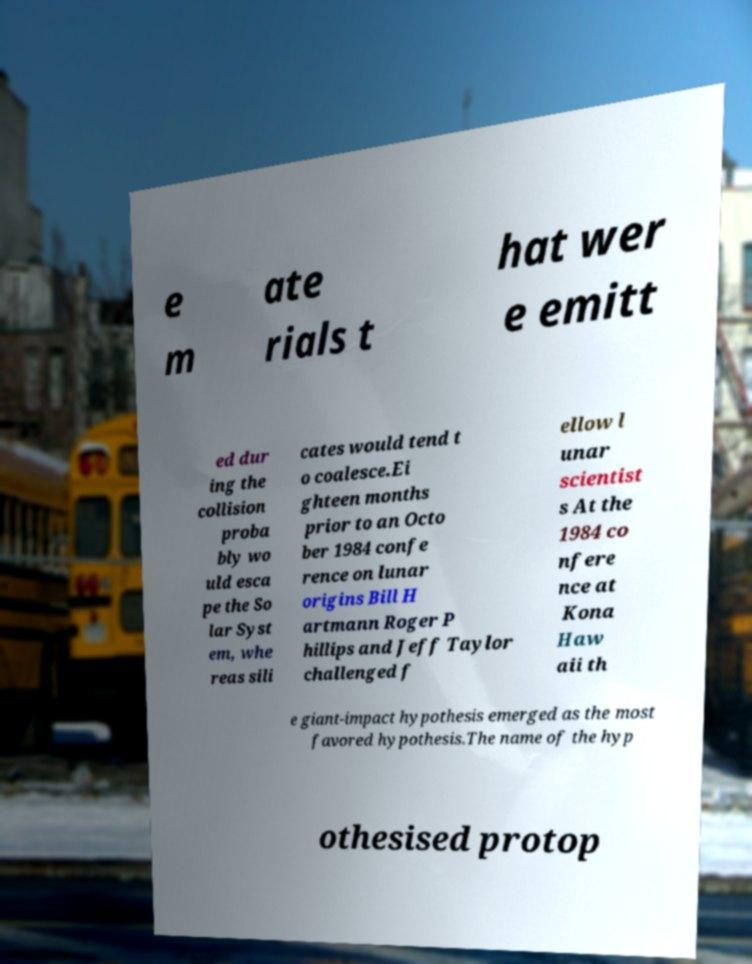Please read and relay the text visible in this image. What does it say? e m ate rials t hat wer e emitt ed dur ing the collision proba bly wo uld esca pe the So lar Syst em, whe reas sili cates would tend t o coalesce.Ei ghteen months prior to an Octo ber 1984 confe rence on lunar origins Bill H artmann Roger P hillips and Jeff Taylor challenged f ellow l unar scientist s At the 1984 co nfere nce at Kona Haw aii th e giant-impact hypothesis emerged as the most favored hypothesis.The name of the hyp othesised protop 